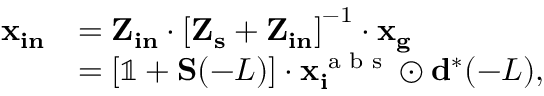<formula> <loc_0><loc_0><loc_500><loc_500>\begin{array} { r l } { x _ { i n } } & { = Z _ { i n } \cdot \left [ Z _ { s } + Z _ { i n } \right ] ^ { - 1 } \cdot x _ { g } } \\ & { = \left [ \mathbb { 1 } + S ( - L ) \right ] \cdot x _ { i } ^ { a b s } \odot d ^ { * } ( - L ) , } \end{array}</formula> 